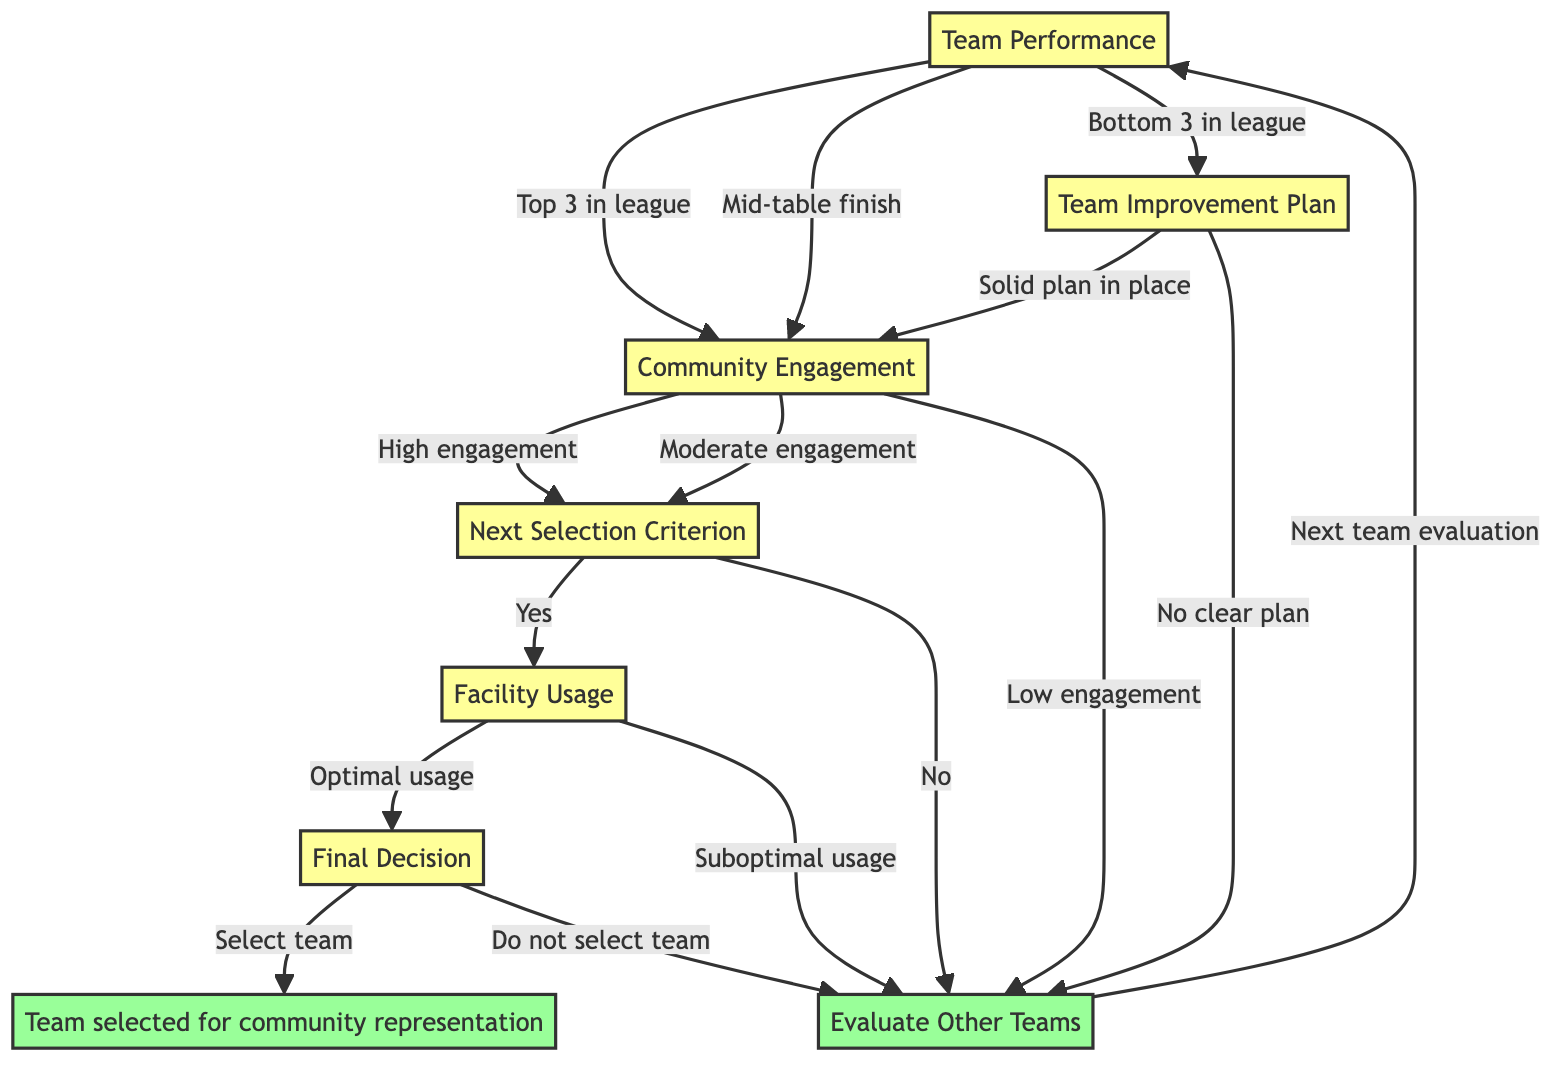What are the three possible outcomes for team performance in the diagram? The diagram outlines three conditions under team performance: Top 3 in league, Mid-table finish, and Bottom 3 in league.
Answer: Top 3 in league, Mid-table finish, Bottom 3 in league What does the "community engagement" stage assess? The community engagement stage evaluates the team’s interaction with the local community, specifically through organized events.
Answer: Engagement with the local community What happens if a team is in the bottom 3 of the league? If a team is in the bottom 3 of the league, it must then go to the "team improvement plan" step to evaluate if there's a plan for improvement.
Answer: Team improvement plan How many conditions need to be satisfied before moving to "facility usage"? Two conditions need to be satisfied: both team performance and community engagement must meet the criteria to proceed to facility usage.
Answer: Two conditions What action is taken at the "final decision" node if a team is selected? If a team is selected at the final decision node, the action taken is that the team is chosen for community representation.
Answer: Team selected for community representation What is the next step if a team shows low community engagement? If a team shows low community engagement (fewer than 2 events per year), the next step is to evaluate other teams.
Answer: Evaluate other teams What is required for a team to be considered for optimal facility usage? A team must demonstrate optimal usage of community sports facilities to continue in the evaluation process.
Answer: Optimal usage What happens if a team does not have a solid improvement plan? If a team does not have a solid improvement plan, it leads to the step that evaluates other teams, thus halting the selection process for that team.
Answer: Evaluate other teams What are the two conditions leading to a "final decision"? The two conditions leading to a final decision are optimal usage of facilities or suboptimal usage, which determines if the team will be selected or not.
Answer: Optimal usage, Suboptimal usage 